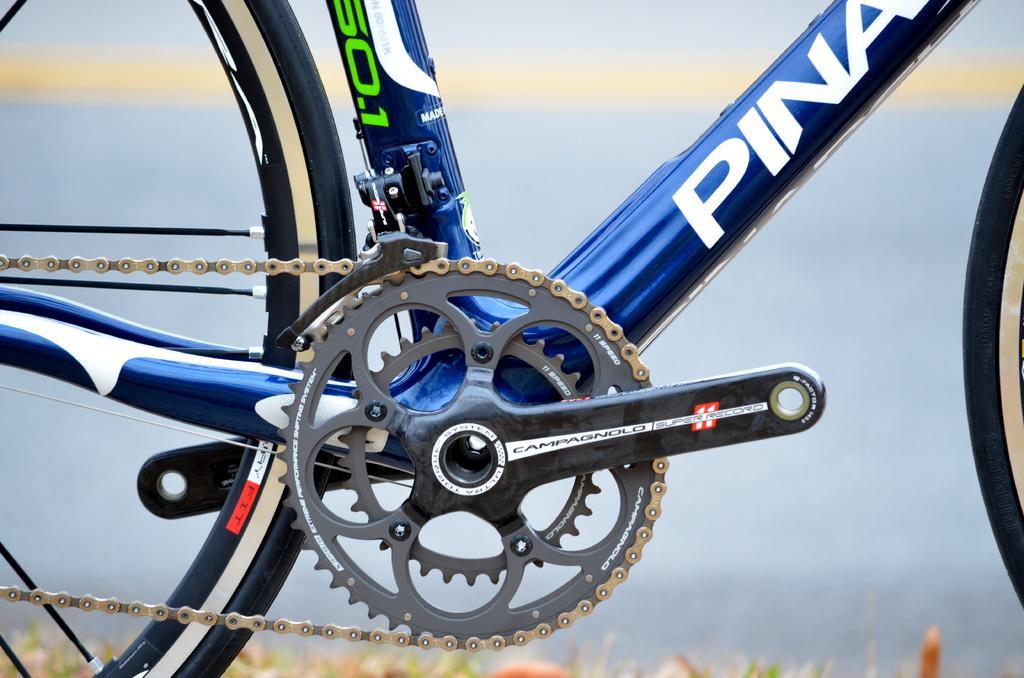Can you describe this image briefly? This is a picture of a bicycle on the ground and in the background, we can see the sky. 